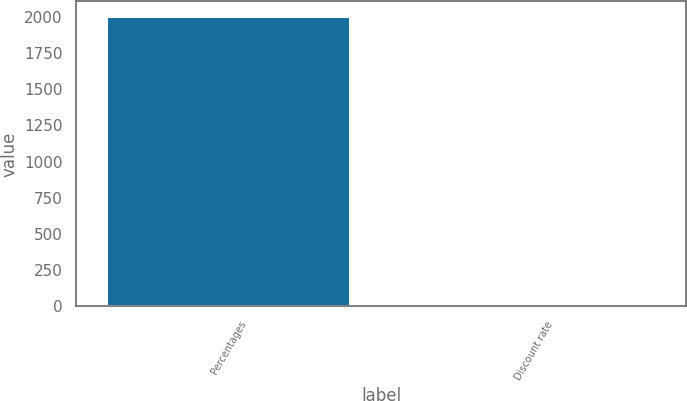Convert chart. <chart><loc_0><loc_0><loc_500><loc_500><bar_chart><fcel>Percentages<fcel>Discount rate<nl><fcel>2007<fcel>6.5<nl></chart> 